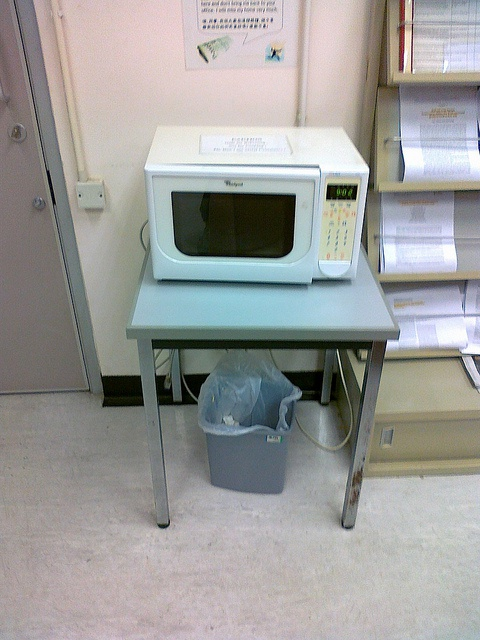Describe the objects in this image and their specific colors. I can see refrigerator in gray, lightgray, and darkgray tones and microwave in gray, white, black, lightblue, and darkgray tones in this image. 